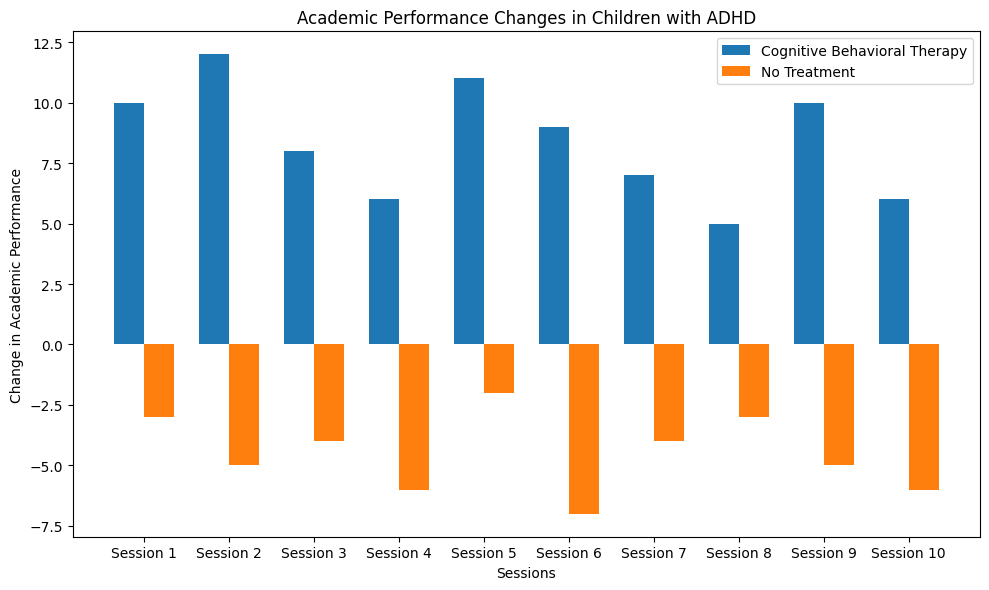What is the average change in academic performance for the children undergoing Cognitive Behavioral Therapy? To find the average change, sum all the changes for Cognitive Behavioral Therapy and divide by the number of sessions. The changes are: 10, 12, 8, 6, 11, 9, 7, 5, 10, 6. The sum is 84, and there are 10 sessions, so the average is 84/10 = 8.4.
Answer: 8.4 Which group had the highest individual change in academic performance? From the figure, the highest positive bar represents the largest individual change. The highest bar for Cognitive Behavioral Therapy is at 12, whereas the highest for No Treatment is -2. Therefore, Cognitive Behavioral Therapy had the highest individual change.
Answer: Cognitive Behavioral Therapy How do the average changes in academic performance compare between the two groups? First calculate the average changes for both groups: for Cognitive Behavioral Therapy it's 8.4 (previously computed), and for No Treatment, sum all the changes (-3, -5, -4, -6, -2, -7, -4, -3, -5, -6) which give -45, and then divide by 10. The average is -45/10 = -4.5. The average for Cognitive Behavioral Therapy (8.4) is higher than for No Treatment (-4.5).
Answer: The average for Cognitive Behavioral Therapy is higher What is the median change in academic performance for the No Treatment group? Arrange the changes for No Treatment in ascending order: -7, -6, -6, -5, -5, -4, -4, -3, -3, -2. The median is the middle value of this ordered list. Since there are 10 values, the median is the average of the 5th and 6th values which are -5 and -4. (-5 + -4) / 2 = -4.5.
Answer: -4.5 What is the total change in academic performance from all the sessions in both groups? Sum the changes for both groups: (10 + 12 + 8 + 6 + 11 + 9 + 7 + 5 + 10 + 6) + (-3 - 5 - 4 - 6 - 2 - 7 - 4 - 3 - 5 - 6). The total change for Cognitive Behavioral Therapy is 84, and for No Treatment, it's -45. The total change in academic performance is 84 - 45 = 39.
Answer: 39 Which group experienced a decrease in academic performance? Compare the changes visually. The changes for Cognitive Behavioral Therapy are all positive, representing improvement. The changes for No Treatment are all negative, representing a decrease.
Answer: No Treatment Looking at the bars’ heights, which group experienced a more consistent change in academic performance? The height of the bars for Cognitive Behavioral Therapy is more consistent around values slightly above or slightly below 10. For No Treatment, the bars are more scattered around negative values varying from -2 to -7. Therefore, Cognitive Behavioral Therapy shows more consistency.
Answer: Cognitive Behavioral Therapy 